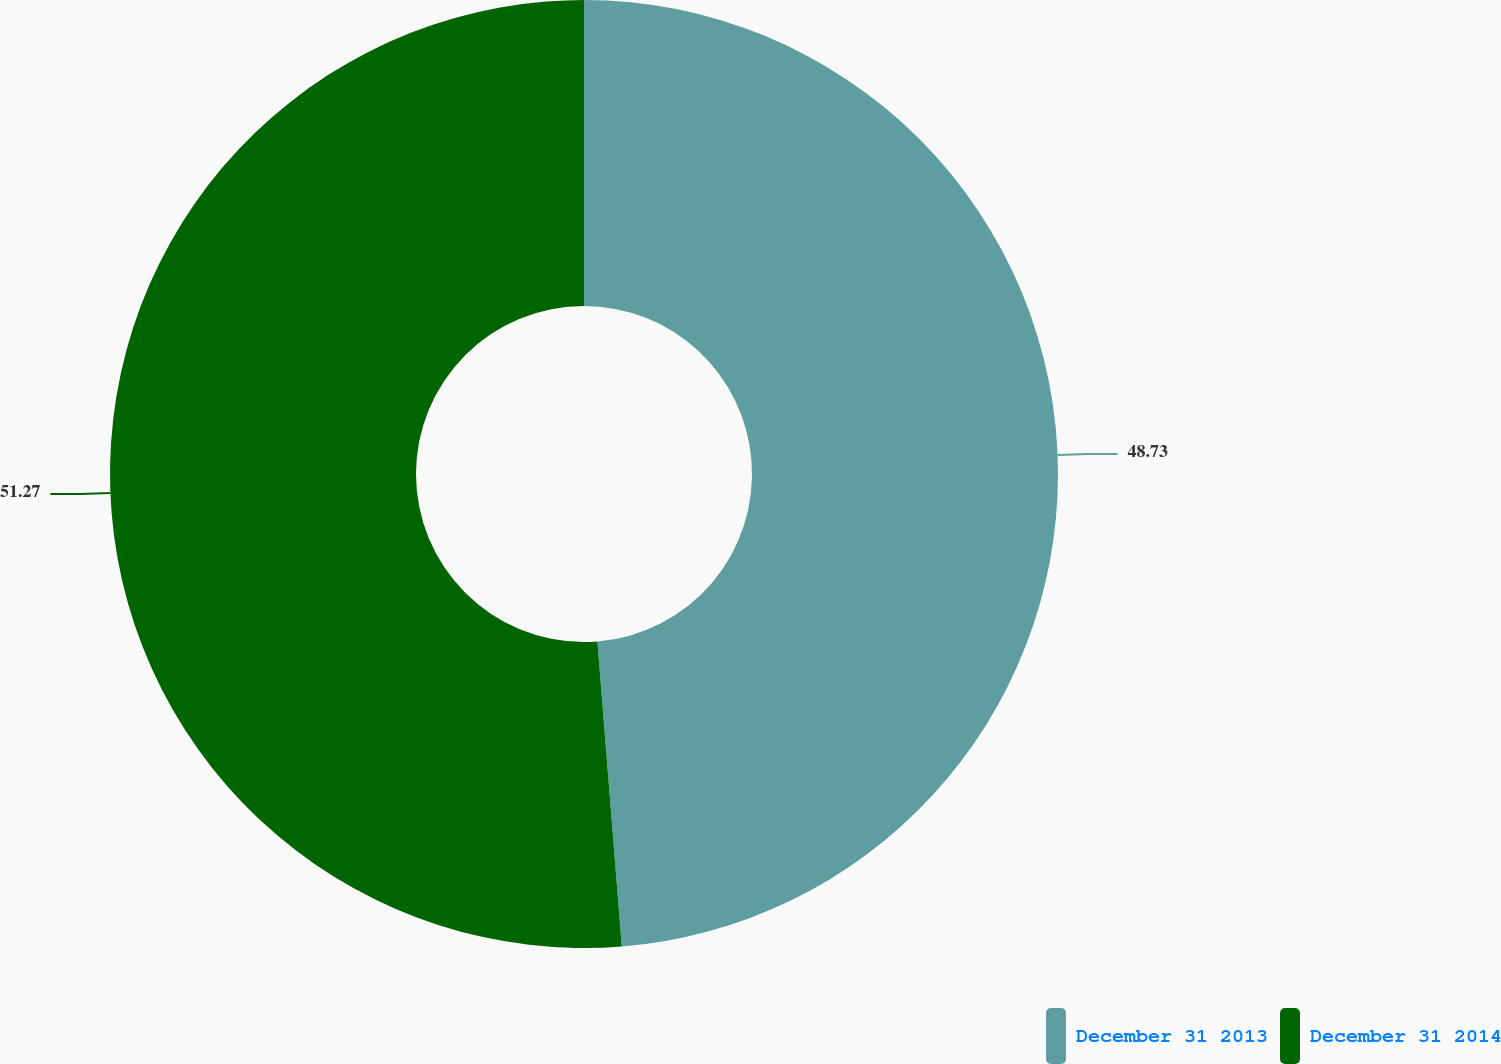<chart> <loc_0><loc_0><loc_500><loc_500><pie_chart><fcel>December 31 2013<fcel>December 31 2014<nl><fcel>48.73%<fcel>51.27%<nl></chart> 